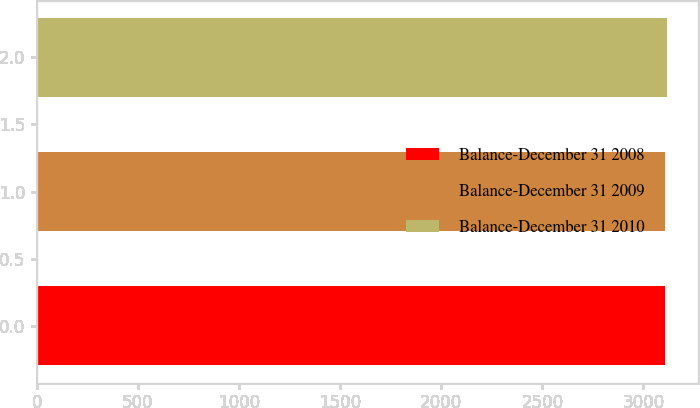Convert chart. <chart><loc_0><loc_0><loc_500><loc_500><bar_chart><fcel>Balance-December 31 2008<fcel>Balance-December 31 2009<fcel>Balance-December 31 2010<nl><fcel>3108<fcel>3108.6<fcel>3114<nl></chart> 